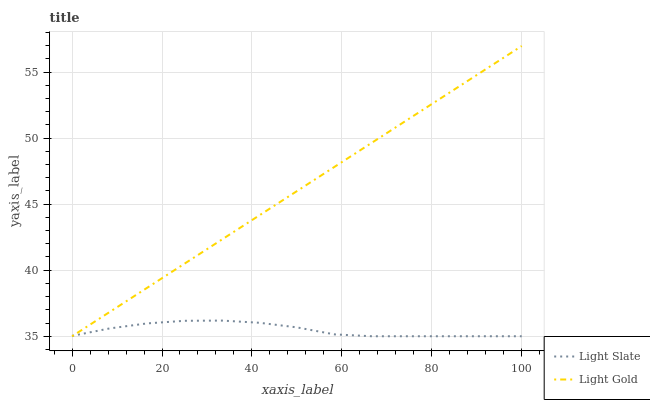Does Light Slate have the minimum area under the curve?
Answer yes or no. Yes. Does Light Gold have the maximum area under the curve?
Answer yes or no. Yes. Does Light Gold have the minimum area under the curve?
Answer yes or no. No. Is Light Gold the smoothest?
Answer yes or no. Yes. Is Light Slate the roughest?
Answer yes or no. Yes. Is Light Gold the roughest?
Answer yes or no. No. Does Light Slate have the lowest value?
Answer yes or no. Yes. Does Light Gold have the highest value?
Answer yes or no. Yes. Does Light Gold intersect Light Slate?
Answer yes or no. Yes. Is Light Gold less than Light Slate?
Answer yes or no. No. Is Light Gold greater than Light Slate?
Answer yes or no. No. 